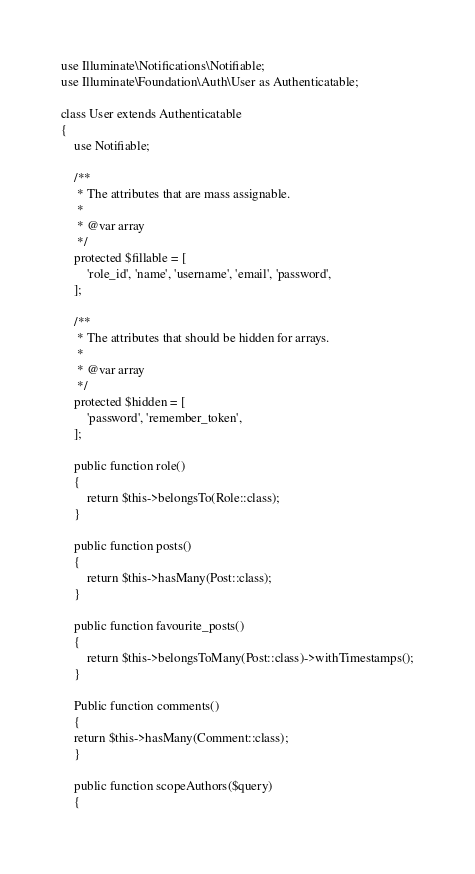Convert code to text. <code><loc_0><loc_0><loc_500><loc_500><_PHP_>use Illuminate\Notifications\Notifiable;
use Illuminate\Foundation\Auth\User as Authenticatable;

class User extends Authenticatable
{
    use Notifiable;

    /**
     * The attributes that are mass assignable.
     *
     * @var array
     */
    protected $fillable = [
        'role_id', 'name', 'username', 'email', 'password',
    ];

    /**
     * The attributes that should be hidden for arrays.
     *
     * @var array
     */
    protected $hidden = [
        'password', 'remember_token',
    ];

    public function role()
    {
        return $this->belongsTo(Role::class);
    }

    public function posts()
    {
        return $this->hasMany(Post::class);
    }

    public function favourite_posts()
    {
        return $this->belongsToMany(Post::class)->withTimestamps();
    }
    
    Public function comments()
    {
    return $this->hasMany(Comment::class);
    }

    public function scopeAuthors($query)
    {</code> 